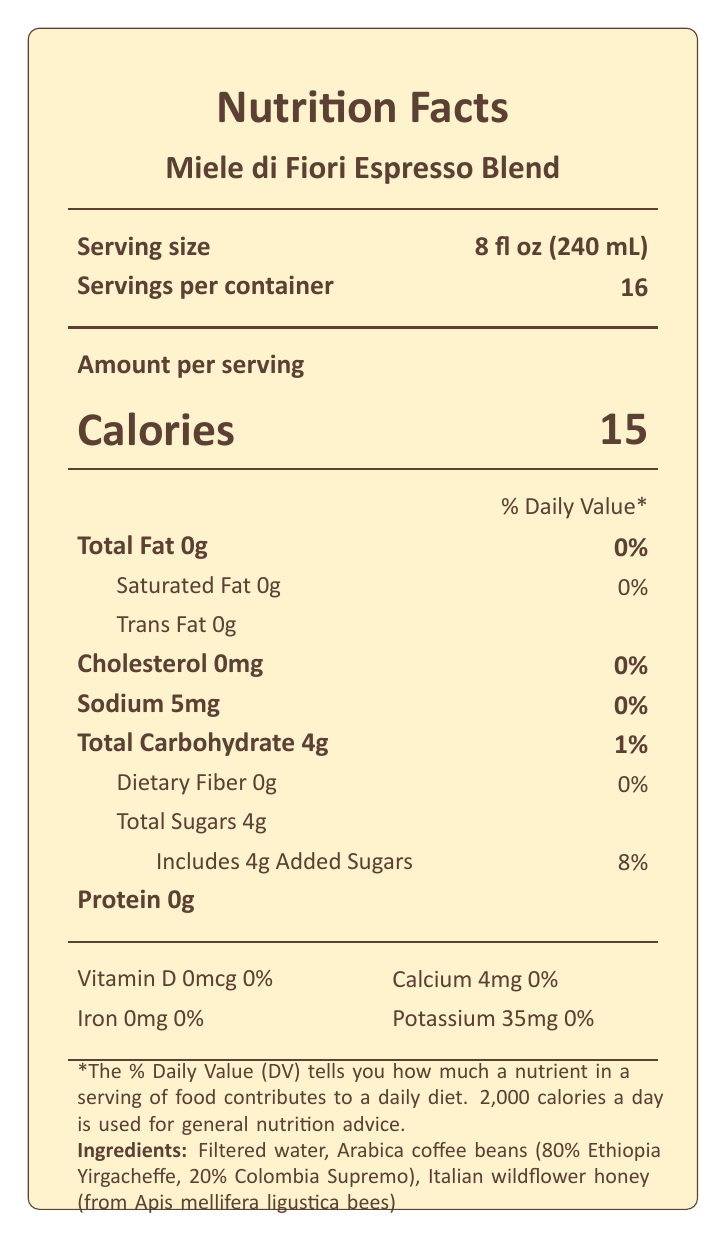what is the serving size? The serving size is listed at the top of the label.
Answer: 8 fl oz (240 mL) how many servings are in one container? The number of servings per container is listed just below the serving size.
Answer: 16 How many calories are in one serving? The calories per serving are displayed prominently near the top of the label.
Answer: 15 what is the total carbohydrate content per serving? The total carbohydrate content per serving is listed under “Total Carbohydrate”.
Answer: 4g how much added sugar does the product contain per serving? The amount of added sugars is listed under "Includes Added Sugars".
Answer: 4g What is the sodium content in this coffee blend? The sodium content is found under the "Sodium" section of the Nutrition Facts.
Answer: 5mg how much protein is in one serving? The protein content per serving is listed as 0g under the "Protein" section.
Answer: 0g what is the source of honey used in the coffee blend? The ingredients list specifies that the honey is wildflower honey from Italian honeybees (Apis mellifera ligustica).
Answer: Italian wildflower honey from Apis mellifera ligustica bees what are the caffeine content and its origin of honey? A. 95mg, Tuscany, Italy B. 85mg, Sicily, Italy C. 60mg, Piedmont, Italy The additional information specifies that the caffeine content is 95mg per serving, and the honey origin is Tuscany, Italy.
Answer: A which origin is the Ethiopian coffee bean used in this blend? A. Sidamo B. Yirgacheffe C. Harrar D. Djimmah The ingredient list mentions that 80% of the coffee beans in this blend are from Ethiopia Yirgacheffe.
Answer: B is this product allergen-free? The allergen info states that it is processed in a facility that also processes tree nuts and dairy.
Answer: No summarize the main idea of the document. The document provides comprehensive nutritional and ingredient information about the honey-infused coffee blend, elaborating on the specific nutrients, ingredients, and additional details like caffeine content and sustainability certification.
Answer: The document is a Nutrition Facts Label for "Miele di Fiori Espresso Blend," a honey-infused coffee featuring wildflower honey from Italian honeybees. It provides details about the serving size, servings per container, calorie count, nutrient information, ingredients, allergen information, caffeine content, honey origin, coffee roast level, flavor notes, and sustainability certification. how much dietary fiber does this coffee contain? The dietary fiber content is listed as 0g under the "Dietary Fiber" section in the Nutrition Facts.
Answer: 0g what kind of certification does the coffee have? Under the additional info, it states that the coffee beans are Rainforest Alliance Certified.
Answer: Rainforest Alliance Certified what is the flavor profile of the coffee blend? The additional information lists the flavor notes as floral, citrus, and caramel.
Answer: Floral, Citrus, Caramel Where in Italy is the honey sourced from? The honey origin is explicitly mentioned as Tuscany, Italy.
Answer: Tuscany What is the total fat content in one serving, and what percentage of the daily value does this represent? The total fat content is listed as 0g, which represents 0% of the daily value.
Answer: 0g, 0% what is the primary question people might have about the origin of the honeybee species the honey is sourced from? The document states the type of honeybee species and the origin of the honey, but it does not provide detailed information about the characteristics or unique traits of the honeybee species.
Answer: Not enough information 